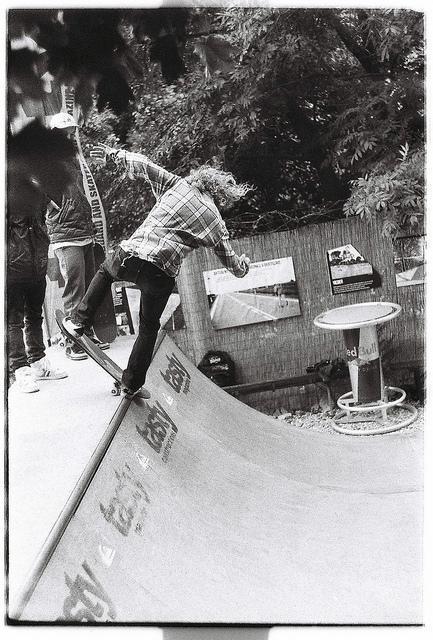How many people are there?
Give a very brief answer. 4. How many oranges can you see?
Give a very brief answer. 0. 